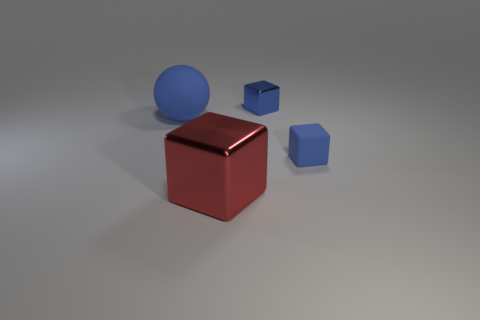How many other objects are the same size as the blue sphere?
Give a very brief answer. 1. Do the large metallic thing and the large blue matte object have the same shape?
Provide a short and direct response. No. How many rubber things are either small purple objects or blue cubes?
Your response must be concise. 1. What number of metallic blocks are there?
Ensure brevity in your answer.  2. There is a sphere that is the same size as the red object; what color is it?
Offer a terse response. Blue. Is the sphere the same size as the red shiny thing?
Keep it short and to the point. Yes. There is a shiny thing that is the same color as the rubber sphere; what is its shape?
Keep it short and to the point. Cube. Is the size of the matte ball the same as the blue thing right of the small metal thing?
Keep it short and to the point. No. What color is the object that is behind the red thing and in front of the big blue matte ball?
Your answer should be compact. Blue. Is the number of red cubes that are in front of the big red metallic object greater than the number of tiny rubber blocks right of the tiny matte cube?
Your answer should be compact. No. 